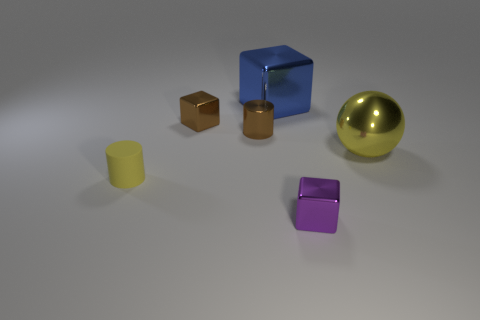The small metal block that is on the right side of the brown shiny thing left of the brown cylinder is what color?
Keep it short and to the point. Purple. There is a tiny purple object; does it have the same shape as the large metal thing left of the large yellow shiny ball?
Your answer should be compact. Yes. What number of other yellow objects have the same size as the rubber thing?
Make the answer very short. 0. What material is the brown object that is the same shape as the large blue shiny thing?
Ensure brevity in your answer.  Metal. There is a metallic block behind the tiny brown cube; is it the same color as the small object that is in front of the yellow matte object?
Give a very brief answer. No. What shape is the small brown thing in front of the brown cube?
Your answer should be very brief. Cylinder. What is the color of the large sphere?
Provide a short and direct response. Yellow. What is the shape of the blue object that is the same material as the big ball?
Provide a short and direct response. Cube. There is a metal block that is in front of the yellow cylinder; is it the same size as the brown metallic block?
Ensure brevity in your answer.  Yes. What number of objects are either tiny shiny cubes behind the brown cylinder or yellow matte objects that are in front of the blue shiny block?
Give a very brief answer. 2. 